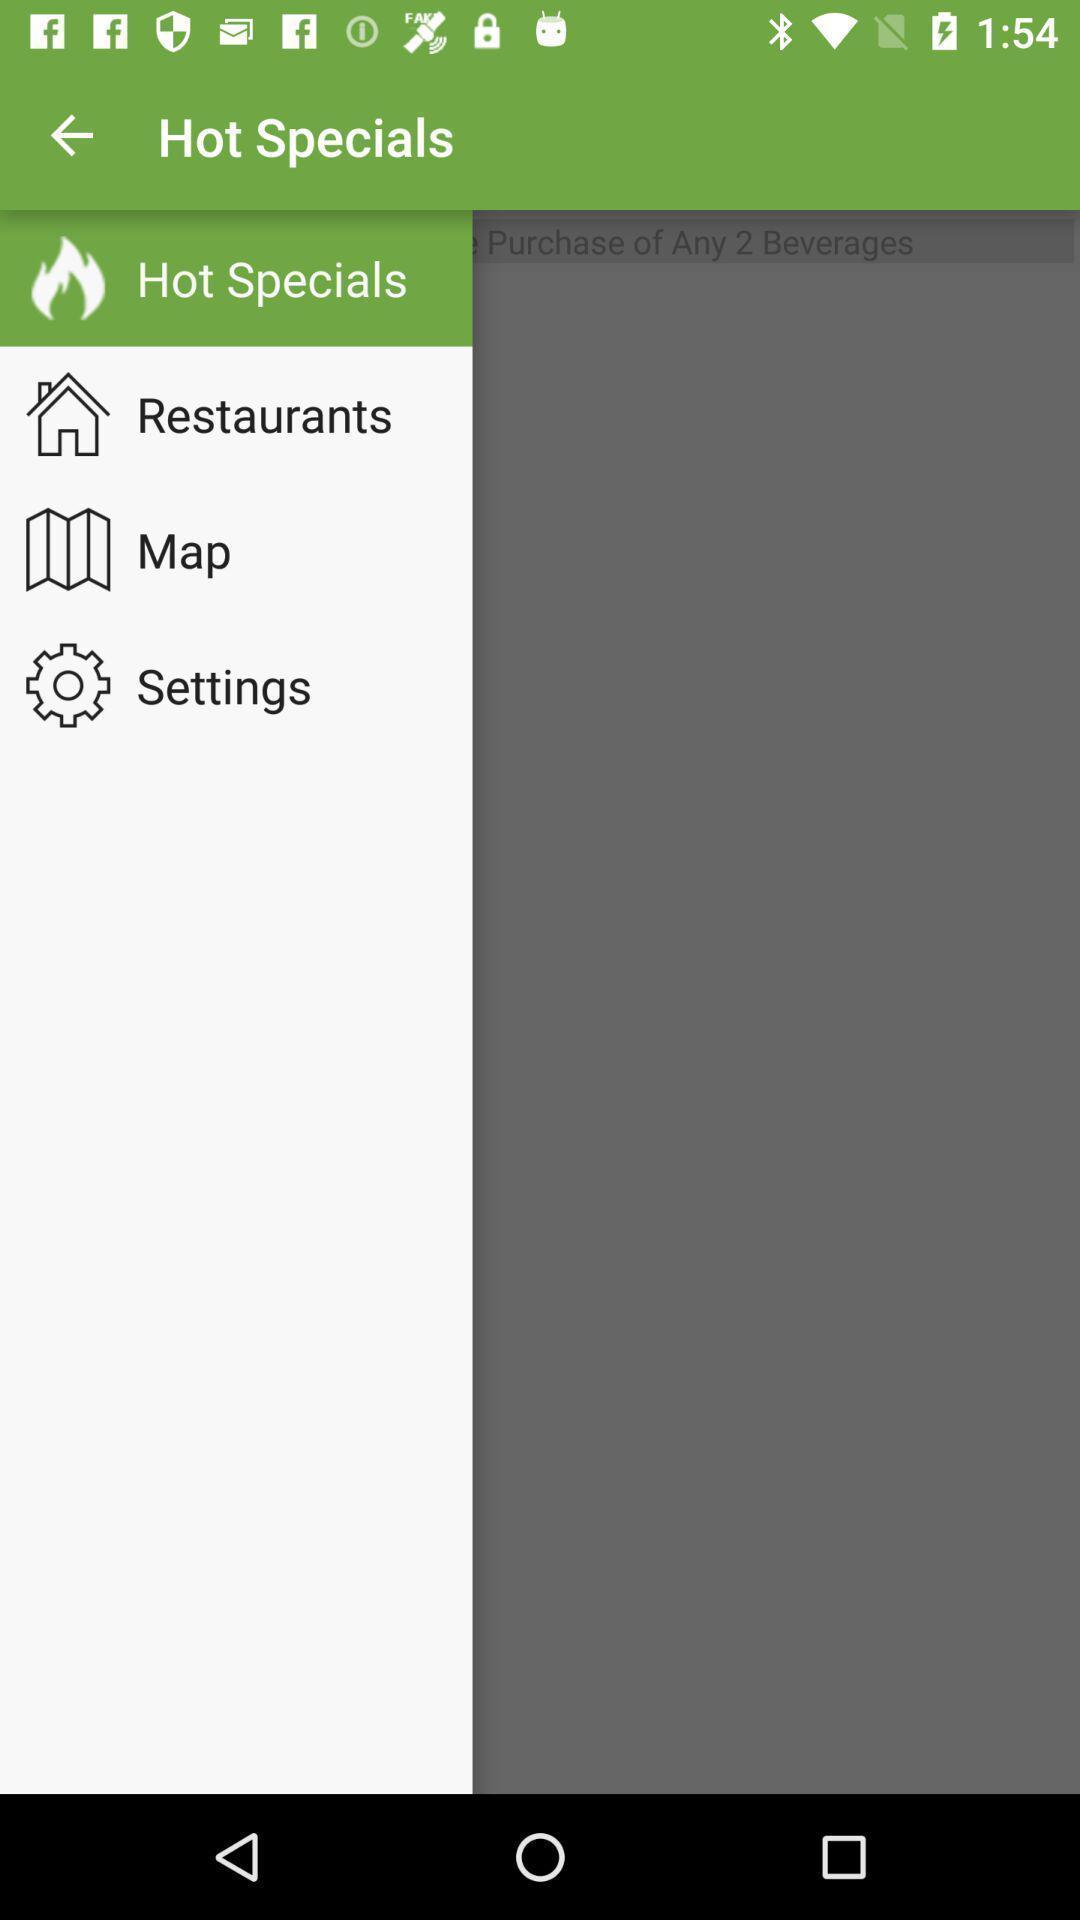Provide a detailed account of this screenshot. Pop up page displayed various options. 